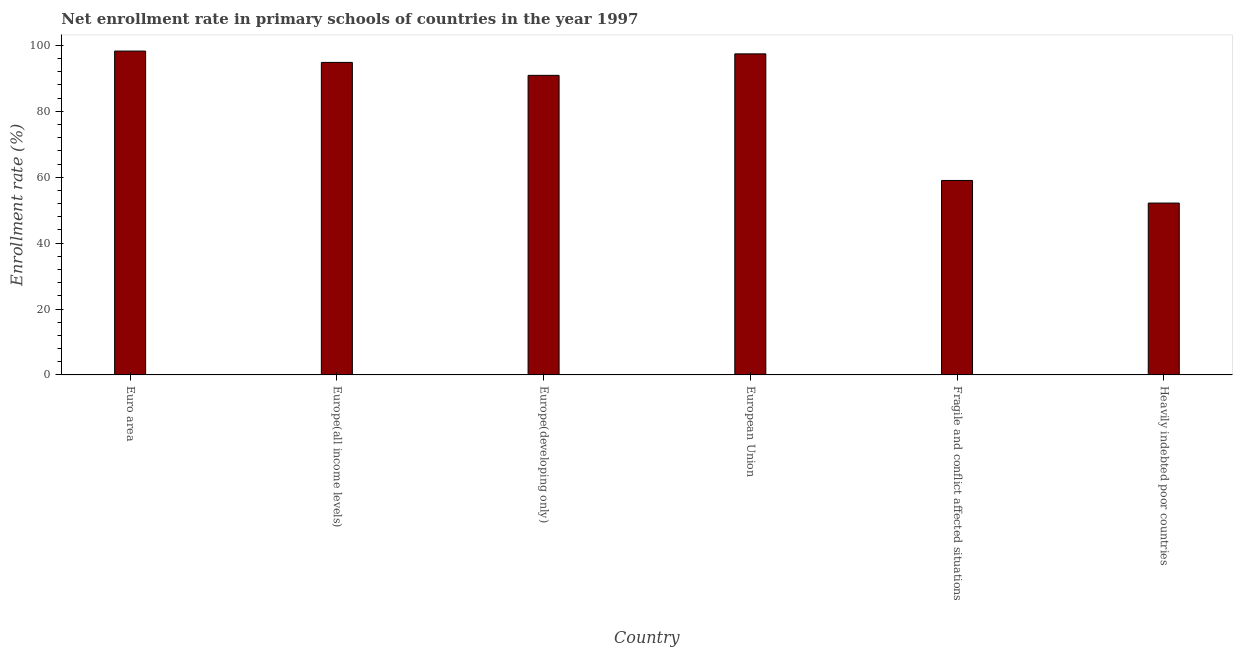What is the title of the graph?
Your answer should be very brief. Net enrollment rate in primary schools of countries in the year 1997. What is the label or title of the X-axis?
Provide a succinct answer. Country. What is the label or title of the Y-axis?
Your response must be concise. Enrollment rate (%). What is the net enrollment rate in primary schools in European Union?
Your answer should be very brief. 97.43. Across all countries, what is the maximum net enrollment rate in primary schools?
Give a very brief answer. 98.28. Across all countries, what is the minimum net enrollment rate in primary schools?
Offer a very short reply. 52.15. In which country was the net enrollment rate in primary schools minimum?
Give a very brief answer. Heavily indebted poor countries. What is the sum of the net enrollment rate in primary schools?
Offer a terse response. 492.63. What is the difference between the net enrollment rate in primary schools in Europe(developing only) and Heavily indebted poor countries?
Ensure brevity in your answer.  38.76. What is the average net enrollment rate in primary schools per country?
Keep it short and to the point. 82.1. What is the median net enrollment rate in primary schools?
Offer a very short reply. 92.88. What is the ratio of the net enrollment rate in primary schools in European Union to that in Fragile and conflict affected situations?
Ensure brevity in your answer.  1.65. Is the difference between the net enrollment rate in primary schools in Europe(developing only) and Fragile and conflict affected situations greater than the difference between any two countries?
Provide a succinct answer. No. What is the difference between the highest and the second highest net enrollment rate in primary schools?
Keep it short and to the point. 0.85. Is the sum of the net enrollment rate in primary schools in Europe(developing only) and Fragile and conflict affected situations greater than the maximum net enrollment rate in primary schools across all countries?
Provide a succinct answer. Yes. What is the difference between the highest and the lowest net enrollment rate in primary schools?
Make the answer very short. 46.13. In how many countries, is the net enrollment rate in primary schools greater than the average net enrollment rate in primary schools taken over all countries?
Provide a succinct answer. 4. How many bars are there?
Provide a succinct answer. 6. Are all the bars in the graph horizontal?
Provide a short and direct response. No. What is the difference between two consecutive major ticks on the Y-axis?
Make the answer very short. 20. Are the values on the major ticks of Y-axis written in scientific E-notation?
Give a very brief answer. No. What is the Enrollment rate (%) of Euro area?
Your answer should be very brief. 98.28. What is the Enrollment rate (%) of Europe(all income levels)?
Your answer should be compact. 94.84. What is the Enrollment rate (%) in Europe(developing only)?
Offer a terse response. 90.91. What is the Enrollment rate (%) in European Union?
Keep it short and to the point. 97.43. What is the Enrollment rate (%) of Fragile and conflict affected situations?
Offer a very short reply. 59.01. What is the Enrollment rate (%) of Heavily indebted poor countries?
Keep it short and to the point. 52.15. What is the difference between the Enrollment rate (%) in Euro area and Europe(all income levels)?
Your answer should be compact. 3.44. What is the difference between the Enrollment rate (%) in Euro area and Europe(developing only)?
Provide a succinct answer. 7.37. What is the difference between the Enrollment rate (%) in Euro area and European Union?
Provide a short and direct response. 0.85. What is the difference between the Enrollment rate (%) in Euro area and Fragile and conflict affected situations?
Offer a terse response. 39.27. What is the difference between the Enrollment rate (%) in Euro area and Heavily indebted poor countries?
Give a very brief answer. 46.13. What is the difference between the Enrollment rate (%) in Europe(all income levels) and Europe(developing only)?
Your response must be concise. 3.93. What is the difference between the Enrollment rate (%) in Europe(all income levels) and European Union?
Offer a terse response. -2.59. What is the difference between the Enrollment rate (%) in Europe(all income levels) and Fragile and conflict affected situations?
Ensure brevity in your answer.  35.83. What is the difference between the Enrollment rate (%) in Europe(all income levels) and Heavily indebted poor countries?
Give a very brief answer. 42.69. What is the difference between the Enrollment rate (%) in Europe(developing only) and European Union?
Your answer should be very brief. -6.52. What is the difference between the Enrollment rate (%) in Europe(developing only) and Fragile and conflict affected situations?
Make the answer very short. 31.9. What is the difference between the Enrollment rate (%) in Europe(developing only) and Heavily indebted poor countries?
Your response must be concise. 38.76. What is the difference between the Enrollment rate (%) in European Union and Fragile and conflict affected situations?
Offer a terse response. 38.42. What is the difference between the Enrollment rate (%) in European Union and Heavily indebted poor countries?
Provide a succinct answer. 45.28. What is the difference between the Enrollment rate (%) in Fragile and conflict affected situations and Heavily indebted poor countries?
Offer a terse response. 6.86. What is the ratio of the Enrollment rate (%) in Euro area to that in Europe(all income levels)?
Make the answer very short. 1.04. What is the ratio of the Enrollment rate (%) in Euro area to that in Europe(developing only)?
Ensure brevity in your answer.  1.08. What is the ratio of the Enrollment rate (%) in Euro area to that in Fragile and conflict affected situations?
Make the answer very short. 1.67. What is the ratio of the Enrollment rate (%) in Euro area to that in Heavily indebted poor countries?
Provide a short and direct response. 1.89. What is the ratio of the Enrollment rate (%) in Europe(all income levels) to that in Europe(developing only)?
Offer a very short reply. 1.04. What is the ratio of the Enrollment rate (%) in Europe(all income levels) to that in Fragile and conflict affected situations?
Your response must be concise. 1.61. What is the ratio of the Enrollment rate (%) in Europe(all income levels) to that in Heavily indebted poor countries?
Your response must be concise. 1.82. What is the ratio of the Enrollment rate (%) in Europe(developing only) to that in European Union?
Your answer should be very brief. 0.93. What is the ratio of the Enrollment rate (%) in Europe(developing only) to that in Fragile and conflict affected situations?
Offer a very short reply. 1.54. What is the ratio of the Enrollment rate (%) in Europe(developing only) to that in Heavily indebted poor countries?
Your answer should be very brief. 1.74. What is the ratio of the Enrollment rate (%) in European Union to that in Fragile and conflict affected situations?
Your response must be concise. 1.65. What is the ratio of the Enrollment rate (%) in European Union to that in Heavily indebted poor countries?
Make the answer very short. 1.87. What is the ratio of the Enrollment rate (%) in Fragile and conflict affected situations to that in Heavily indebted poor countries?
Ensure brevity in your answer.  1.13. 